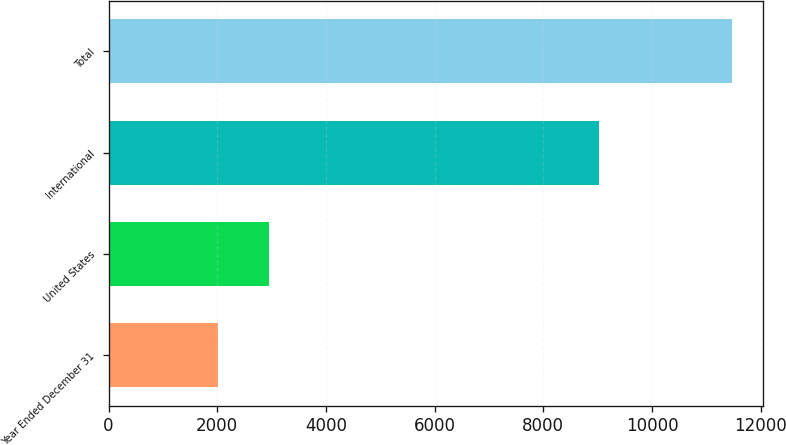Convert chart. <chart><loc_0><loc_0><loc_500><loc_500><bar_chart><fcel>Year Ended December 31<fcel>United States<fcel>International<fcel>Total<nl><fcel>2013<fcel>2959.4<fcel>9026<fcel>11477<nl></chart> 